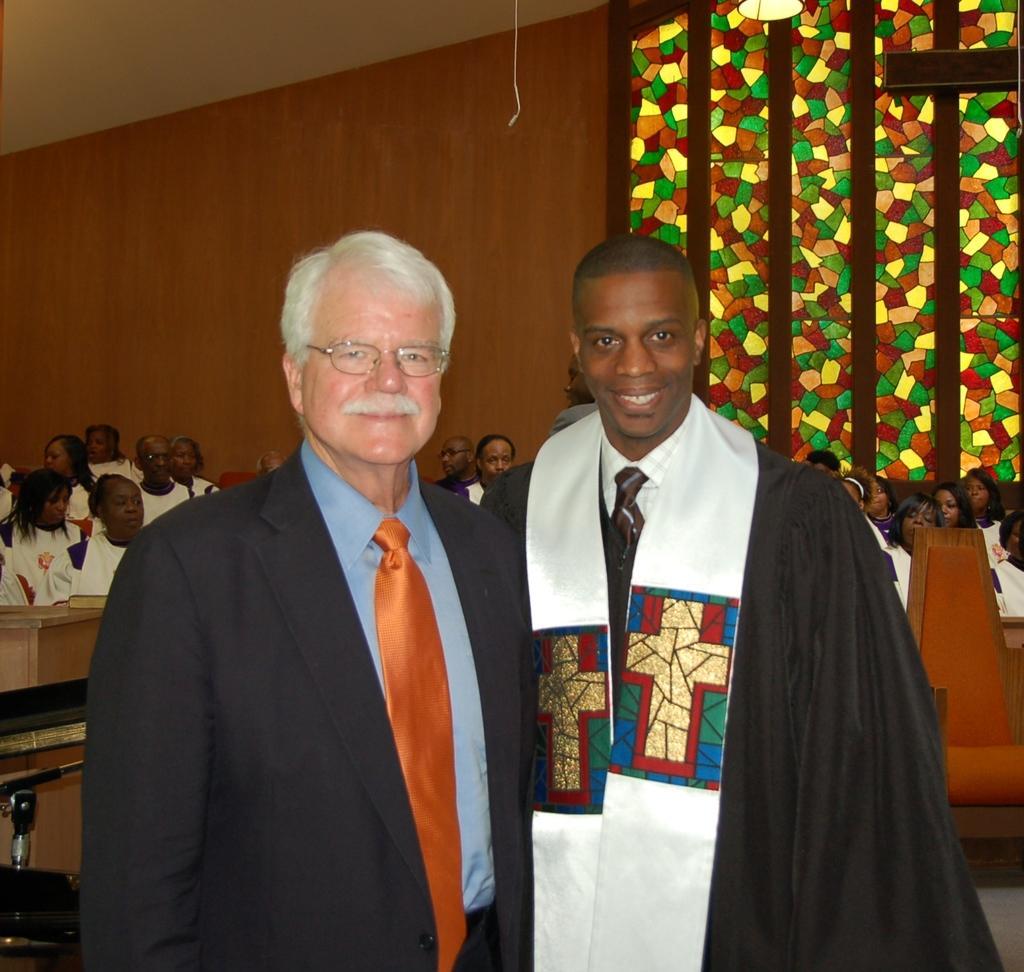How would you summarize this image in a sentence or two? In this picture we can see there are two people standing and other people are sitting. Behind the two people there is a chair and tables. Behind the people there is a wooden wall. At the top there is a light and an object. 